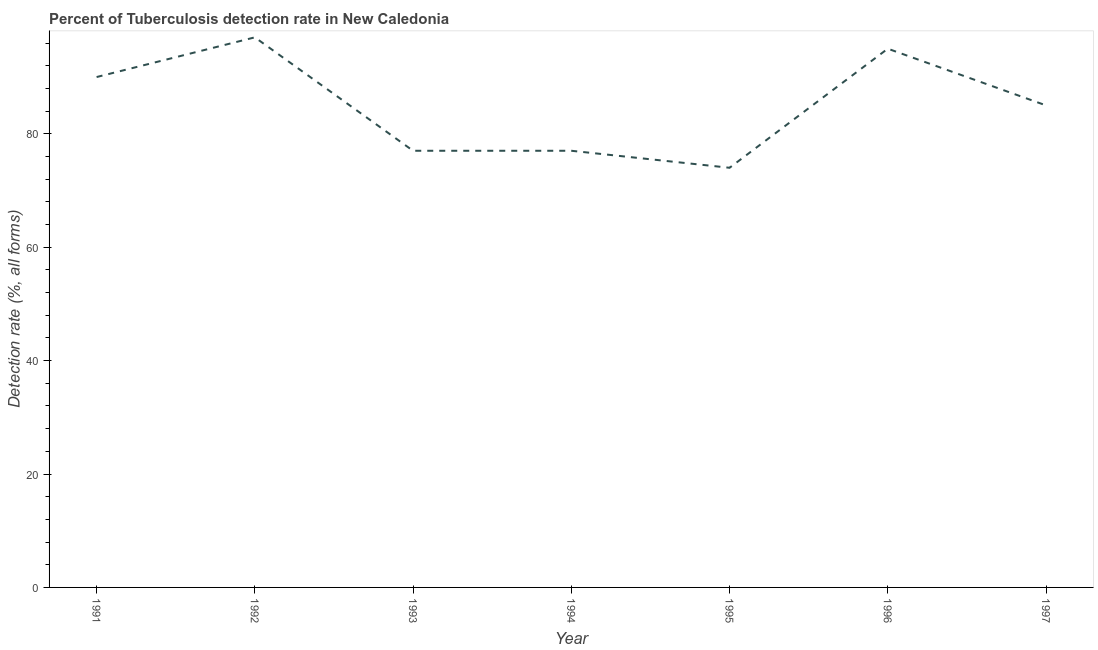What is the detection rate of tuberculosis in 1992?
Keep it short and to the point. 97. Across all years, what is the maximum detection rate of tuberculosis?
Provide a succinct answer. 97. Across all years, what is the minimum detection rate of tuberculosis?
Offer a terse response. 74. In which year was the detection rate of tuberculosis maximum?
Offer a very short reply. 1992. In which year was the detection rate of tuberculosis minimum?
Ensure brevity in your answer.  1995. What is the sum of the detection rate of tuberculosis?
Provide a short and direct response. 595. What is the difference between the detection rate of tuberculosis in 1993 and 1996?
Your answer should be compact. -18. What is the median detection rate of tuberculosis?
Give a very brief answer. 85. What is the ratio of the detection rate of tuberculosis in 1991 to that in 1995?
Make the answer very short. 1.22. Is the detection rate of tuberculosis in 1991 less than that in 1995?
Provide a succinct answer. No. Is the difference between the detection rate of tuberculosis in 1993 and 1996 greater than the difference between any two years?
Offer a very short reply. No. Is the sum of the detection rate of tuberculosis in 1995 and 1996 greater than the maximum detection rate of tuberculosis across all years?
Keep it short and to the point. Yes. What is the difference between the highest and the lowest detection rate of tuberculosis?
Your answer should be very brief. 23. In how many years, is the detection rate of tuberculosis greater than the average detection rate of tuberculosis taken over all years?
Give a very brief answer. 3. Does the detection rate of tuberculosis monotonically increase over the years?
Your response must be concise. No. Are the values on the major ticks of Y-axis written in scientific E-notation?
Offer a very short reply. No. Does the graph contain any zero values?
Your response must be concise. No. What is the title of the graph?
Provide a short and direct response. Percent of Tuberculosis detection rate in New Caledonia. What is the label or title of the X-axis?
Provide a succinct answer. Year. What is the label or title of the Y-axis?
Your answer should be compact. Detection rate (%, all forms). What is the Detection rate (%, all forms) of 1991?
Provide a succinct answer. 90. What is the Detection rate (%, all forms) in 1992?
Offer a terse response. 97. What is the Detection rate (%, all forms) of 1993?
Your answer should be compact. 77. What is the Detection rate (%, all forms) of 1996?
Give a very brief answer. 95. What is the Detection rate (%, all forms) in 1997?
Your answer should be very brief. 85. What is the difference between the Detection rate (%, all forms) in 1991 and 1993?
Your answer should be compact. 13. What is the difference between the Detection rate (%, all forms) in 1991 and 1995?
Give a very brief answer. 16. What is the difference between the Detection rate (%, all forms) in 1991 and 1996?
Provide a short and direct response. -5. What is the difference between the Detection rate (%, all forms) in 1991 and 1997?
Your answer should be compact. 5. What is the difference between the Detection rate (%, all forms) in 1992 and 1993?
Your answer should be compact. 20. What is the difference between the Detection rate (%, all forms) in 1993 and 1994?
Ensure brevity in your answer.  0. What is the difference between the Detection rate (%, all forms) in 1993 and 1997?
Offer a terse response. -8. What is the difference between the Detection rate (%, all forms) in 1994 and 1995?
Provide a succinct answer. 3. What is the difference between the Detection rate (%, all forms) in 1994 and 1996?
Your response must be concise. -18. What is the difference between the Detection rate (%, all forms) in 1994 and 1997?
Ensure brevity in your answer.  -8. What is the ratio of the Detection rate (%, all forms) in 1991 to that in 1992?
Your answer should be compact. 0.93. What is the ratio of the Detection rate (%, all forms) in 1991 to that in 1993?
Make the answer very short. 1.17. What is the ratio of the Detection rate (%, all forms) in 1991 to that in 1994?
Your answer should be compact. 1.17. What is the ratio of the Detection rate (%, all forms) in 1991 to that in 1995?
Keep it short and to the point. 1.22. What is the ratio of the Detection rate (%, all forms) in 1991 to that in 1996?
Your answer should be very brief. 0.95. What is the ratio of the Detection rate (%, all forms) in 1991 to that in 1997?
Your answer should be compact. 1.06. What is the ratio of the Detection rate (%, all forms) in 1992 to that in 1993?
Your response must be concise. 1.26. What is the ratio of the Detection rate (%, all forms) in 1992 to that in 1994?
Your response must be concise. 1.26. What is the ratio of the Detection rate (%, all forms) in 1992 to that in 1995?
Offer a very short reply. 1.31. What is the ratio of the Detection rate (%, all forms) in 1992 to that in 1997?
Ensure brevity in your answer.  1.14. What is the ratio of the Detection rate (%, all forms) in 1993 to that in 1994?
Your answer should be compact. 1. What is the ratio of the Detection rate (%, all forms) in 1993 to that in 1995?
Offer a terse response. 1.04. What is the ratio of the Detection rate (%, all forms) in 1993 to that in 1996?
Your answer should be very brief. 0.81. What is the ratio of the Detection rate (%, all forms) in 1993 to that in 1997?
Provide a short and direct response. 0.91. What is the ratio of the Detection rate (%, all forms) in 1994 to that in 1995?
Offer a terse response. 1.04. What is the ratio of the Detection rate (%, all forms) in 1994 to that in 1996?
Provide a succinct answer. 0.81. What is the ratio of the Detection rate (%, all forms) in 1994 to that in 1997?
Your answer should be very brief. 0.91. What is the ratio of the Detection rate (%, all forms) in 1995 to that in 1996?
Your response must be concise. 0.78. What is the ratio of the Detection rate (%, all forms) in 1995 to that in 1997?
Your response must be concise. 0.87. What is the ratio of the Detection rate (%, all forms) in 1996 to that in 1997?
Provide a succinct answer. 1.12. 